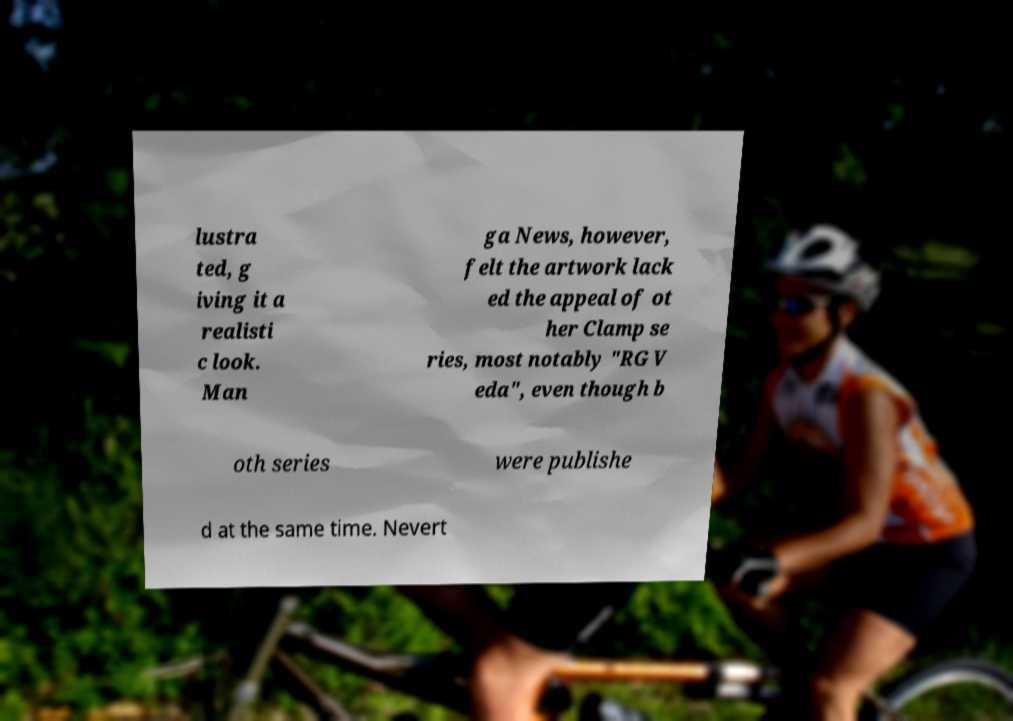What messages or text are displayed in this image? I need them in a readable, typed format. lustra ted, g iving it a realisti c look. Man ga News, however, felt the artwork lack ed the appeal of ot her Clamp se ries, most notably "RG V eda", even though b oth series were publishe d at the same time. Nevert 